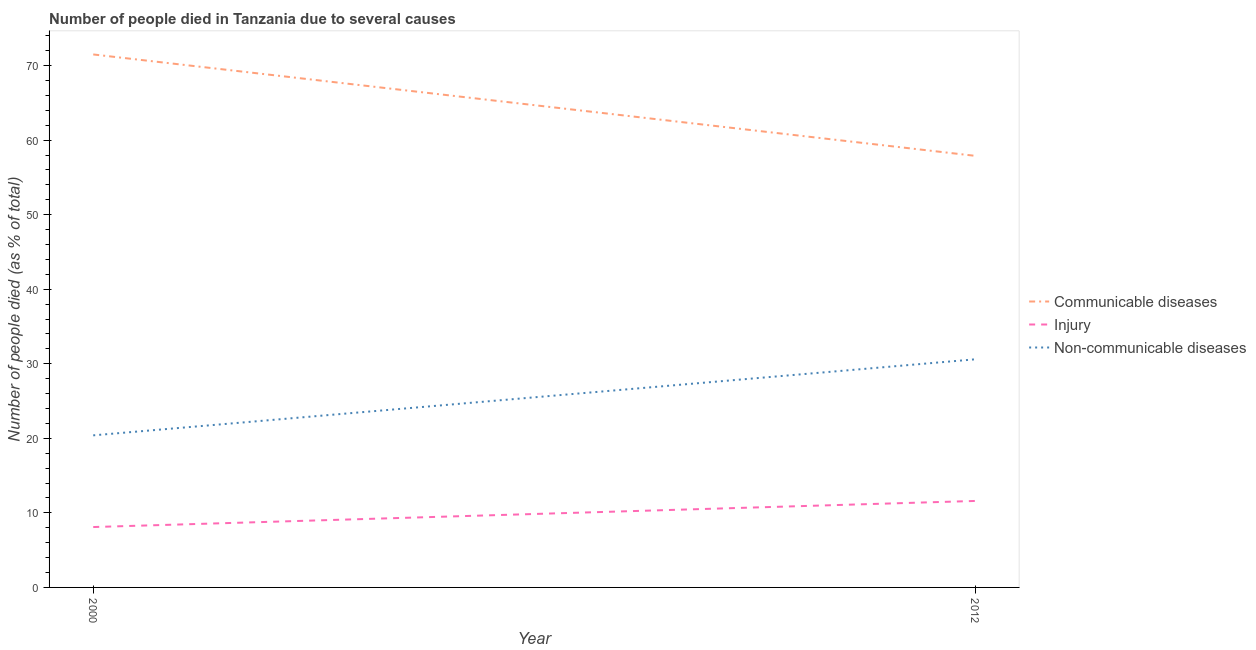How many different coloured lines are there?
Your response must be concise. 3. Does the line corresponding to number of people who died of communicable diseases intersect with the line corresponding to number of people who dies of non-communicable diseases?
Provide a succinct answer. No. Is the number of lines equal to the number of legend labels?
Ensure brevity in your answer.  Yes. What is the number of people who dies of non-communicable diseases in 2000?
Offer a very short reply. 20.4. Across all years, what is the minimum number of people who died of communicable diseases?
Offer a very short reply. 57.9. In which year was the number of people who dies of non-communicable diseases minimum?
Keep it short and to the point. 2000. What is the total number of people who died of communicable diseases in the graph?
Offer a terse response. 129.4. What is the average number of people who died of communicable diseases per year?
Your answer should be very brief. 64.7. In the year 2012, what is the difference between the number of people who died of injury and number of people who died of communicable diseases?
Make the answer very short. -46.3. What is the ratio of the number of people who dies of non-communicable diseases in 2000 to that in 2012?
Offer a very short reply. 0.67. In how many years, is the number of people who dies of non-communicable diseases greater than the average number of people who dies of non-communicable diseases taken over all years?
Give a very brief answer. 1. Does the graph contain grids?
Keep it short and to the point. No. Where does the legend appear in the graph?
Keep it short and to the point. Center right. How are the legend labels stacked?
Keep it short and to the point. Vertical. What is the title of the graph?
Make the answer very short. Number of people died in Tanzania due to several causes. Does "Slovak Republic" appear as one of the legend labels in the graph?
Offer a very short reply. No. What is the label or title of the X-axis?
Keep it short and to the point. Year. What is the label or title of the Y-axis?
Your answer should be very brief. Number of people died (as % of total). What is the Number of people died (as % of total) in Communicable diseases in 2000?
Make the answer very short. 71.5. What is the Number of people died (as % of total) in Non-communicable diseases in 2000?
Make the answer very short. 20.4. What is the Number of people died (as % of total) of Communicable diseases in 2012?
Your answer should be compact. 57.9. What is the Number of people died (as % of total) in Non-communicable diseases in 2012?
Ensure brevity in your answer.  30.6. Across all years, what is the maximum Number of people died (as % of total) in Communicable diseases?
Provide a short and direct response. 71.5. Across all years, what is the maximum Number of people died (as % of total) of Injury?
Provide a succinct answer. 11.6. Across all years, what is the maximum Number of people died (as % of total) of Non-communicable diseases?
Offer a very short reply. 30.6. Across all years, what is the minimum Number of people died (as % of total) in Communicable diseases?
Your answer should be compact. 57.9. Across all years, what is the minimum Number of people died (as % of total) of Injury?
Provide a short and direct response. 8.1. Across all years, what is the minimum Number of people died (as % of total) of Non-communicable diseases?
Provide a short and direct response. 20.4. What is the total Number of people died (as % of total) in Communicable diseases in the graph?
Your response must be concise. 129.4. What is the total Number of people died (as % of total) of Injury in the graph?
Your response must be concise. 19.7. What is the difference between the Number of people died (as % of total) of Communicable diseases in 2000 and the Number of people died (as % of total) of Injury in 2012?
Your answer should be very brief. 59.9. What is the difference between the Number of people died (as % of total) in Communicable diseases in 2000 and the Number of people died (as % of total) in Non-communicable diseases in 2012?
Offer a very short reply. 40.9. What is the difference between the Number of people died (as % of total) of Injury in 2000 and the Number of people died (as % of total) of Non-communicable diseases in 2012?
Make the answer very short. -22.5. What is the average Number of people died (as % of total) of Communicable diseases per year?
Make the answer very short. 64.7. What is the average Number of people died (as % of total) of Injury per year?
Make the answer very short. 9.85. What is the average Number of people died (as % of total) in Non-communicable diseases per year?
Keep it short and to the point. 25.5. In the year 2000, what is the difference between the Number of people died (as % of total) of Communicable diseases and Number of people died (as % of total) of Injury?
Give a very brief answer. 63.4. In the year 2000, what is the difference between the Number of people died (as % of total) in Communicable diseases and Number of people died (as % of total) in Non-communicable diseases?
Keep it short and to the point. 51.1. In the year 2012, what is the difference between the Number of people died (as % of total) in Communicable diseases and Number of people died (as % of total) in Injury?
Offer a terse response. 46.3. In the year 2012, what is the difference between the Number of people died (as % of total) in Communicable diseases and Number of people died (as % of total) in Non-communicable diseases?
Your response must be concise. 27.3. What is the ratio of the Number of people died (as % of total) of Communicable diseases in 2000 to that in 2012?
Provide a short and direct response. 1.23. What is the ratio of the Number of people died (as % of total) in Injury in 2000 to that in 2012?
Ensure brevity in your answer.  0.7. What is the difference between the highest and the lowest Number of people died (as % of total) in Communicable diseases?
Provide a short and direct response. 13.6. 